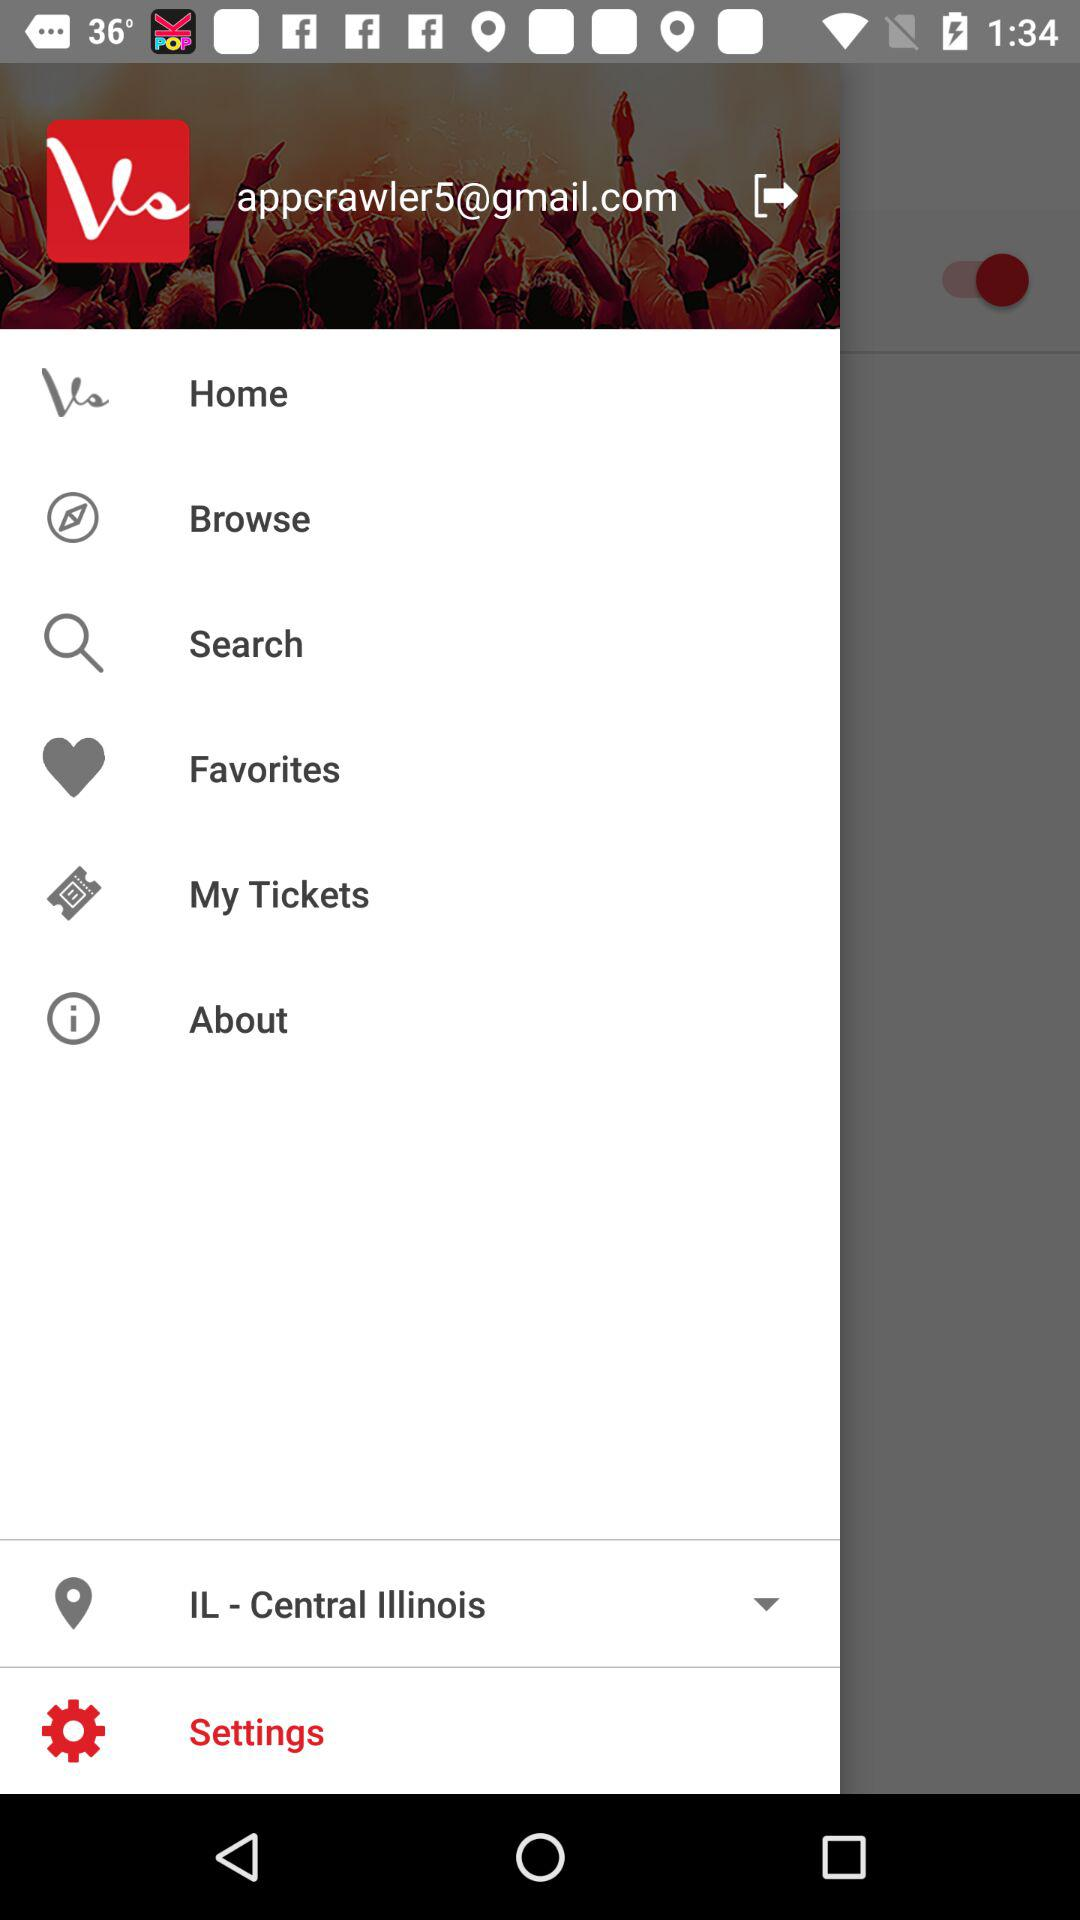What is the email address? The email address is appcrawler5@gmail.com. 